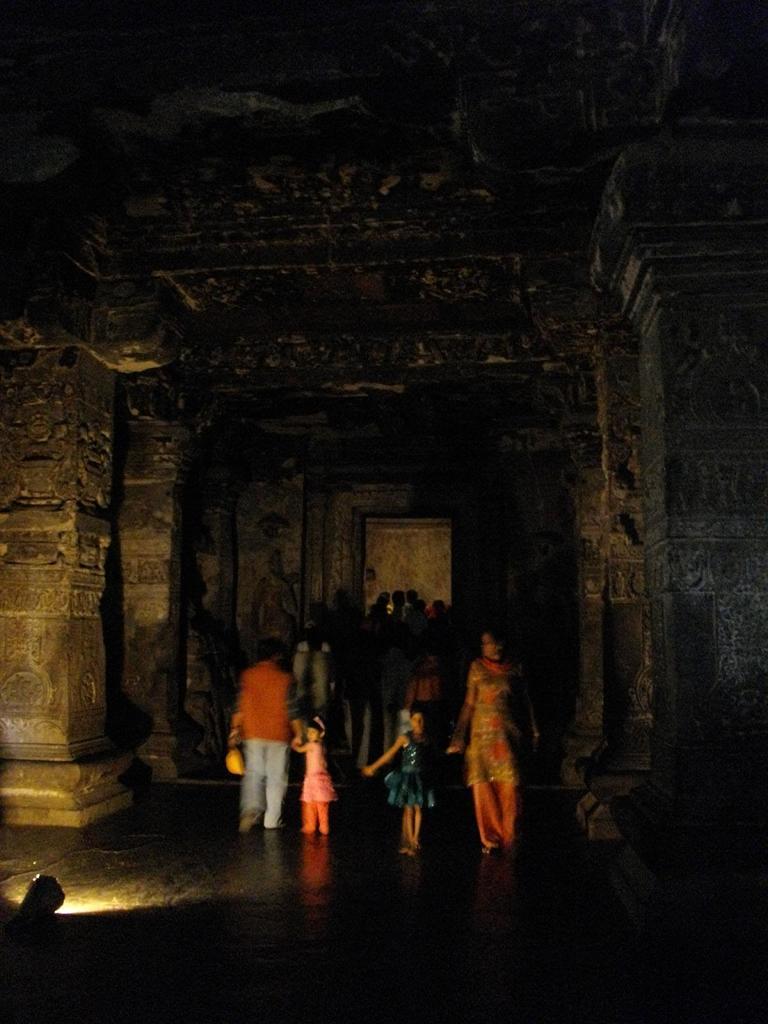Please provide a concise description of this image. In this image I can see a woman wearing orange dress is standing and holding a girl who is wearing a black dress and a person wearing orange shirt, pant is standing and holding a girl wearing orange dress. In the background I can see few other persons standing, few pillars and the ceiling and to the left bottom of the image I can see the light. 